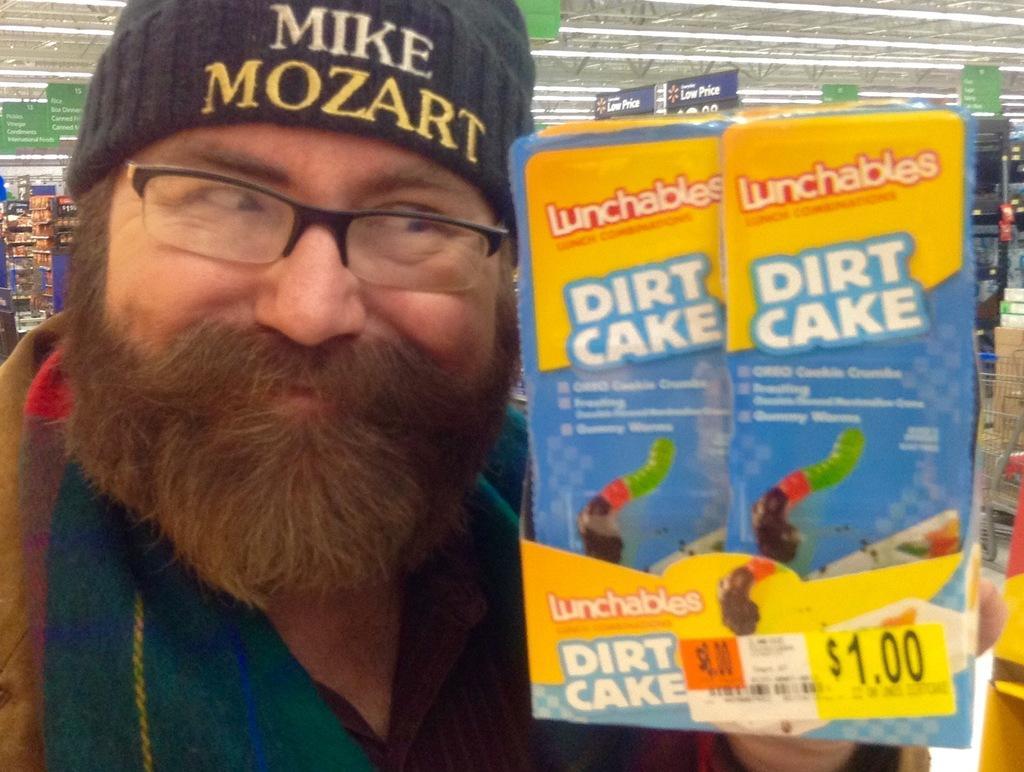In one or two sentences, can you explain what this image depicts? In this image I can see a person holding few cardboard boxes and the boxes are in yellow and blue color. The person is wearing green color shirt, background I can see few objects, boards in green color and I can see few lights. 